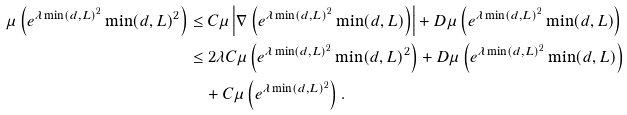Convert formula to latex. <formula><loc_0><loc_0><loc_500><loc_500>\mu \left ( e ^ { \lambda \min ( d , L ) ^ { 2 } } \min ( d , L ) ^ { 2 } \right ) & \leq C \mu \left | \nabla \left ( e ^ { \lambda \min ( d , L ) ^ { 2 } } \min ( d , L ) \right ) \right | + D \mu \left ( e ^ { \lambda \min ( d , L ) ^ { 2 } } \min ( d , L ) \right ) \\ & \leq 2 \lambda C \mu \left ( e ^ { \lambda \min ( d , L ) ^ { 2 } } \min ( d , L ) ^ { 2 } \right ) + D \mu \left ( e ^ { \lambda \min ( d , L ) ^ { 2 } } \min ( d , L ) \right ) \\ & \quad + C \mu \left ( e ^ { \lambda \min ( d , L ) ^ { 2 } } \right ) .</formula> 